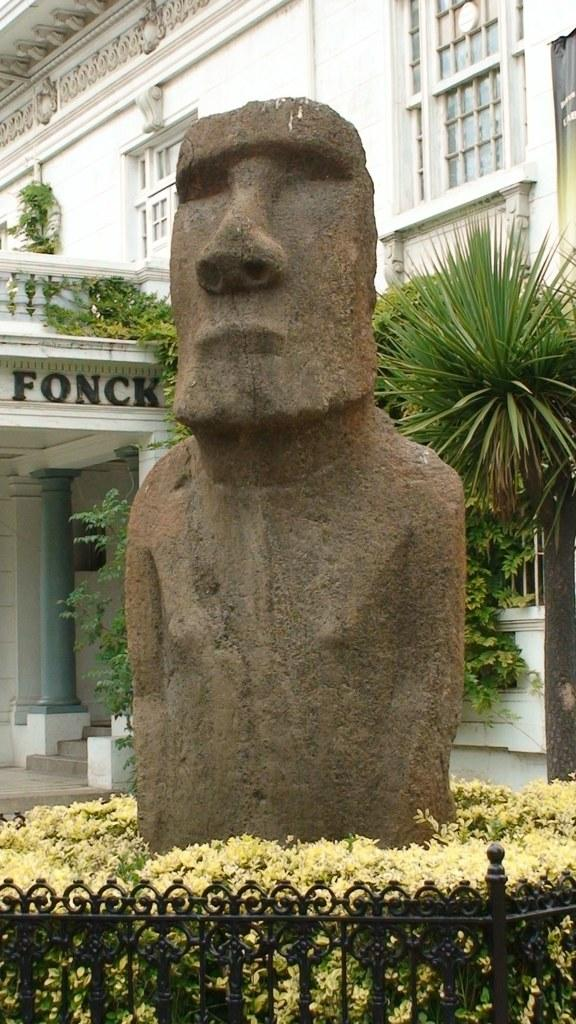What is the main subject of the image? There is a sculpture in the image. What other elements can be seen in the image besides the sculpture? There are plants and a fence visible in the image. What can be seen in the background of the image? There is a building in the background of the image. How many jellyfish are swimming near the sculpture in the image? There are no jellyfish present in the image; it features a sculpture, plants, a fence, and a building in the background. 